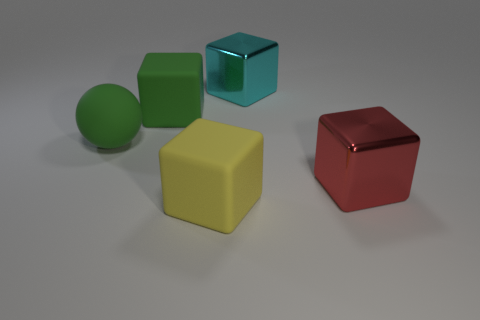Subtract 1 blocks. How many blocks are left? 3 Subtract all large cyan blocks. How many blocks are left? 3 Subtract all brown cubes. Subtract all blue cylinders. How many cubes are left? 4 Add 1 matte blocks. How many objects exist? 6 Subtract all cubes. How many objects are left? 1 Add 2 large rubber spheres. How many large rubber spheres are left? 3 Add 3 tiny cyan balls. How many tiny cyan balls exist? 3 Subtract 0 yellow balls. How many objects are left? 5 Subtract all green rubber spheres. Subtract all balls. How many objects are left? 3 